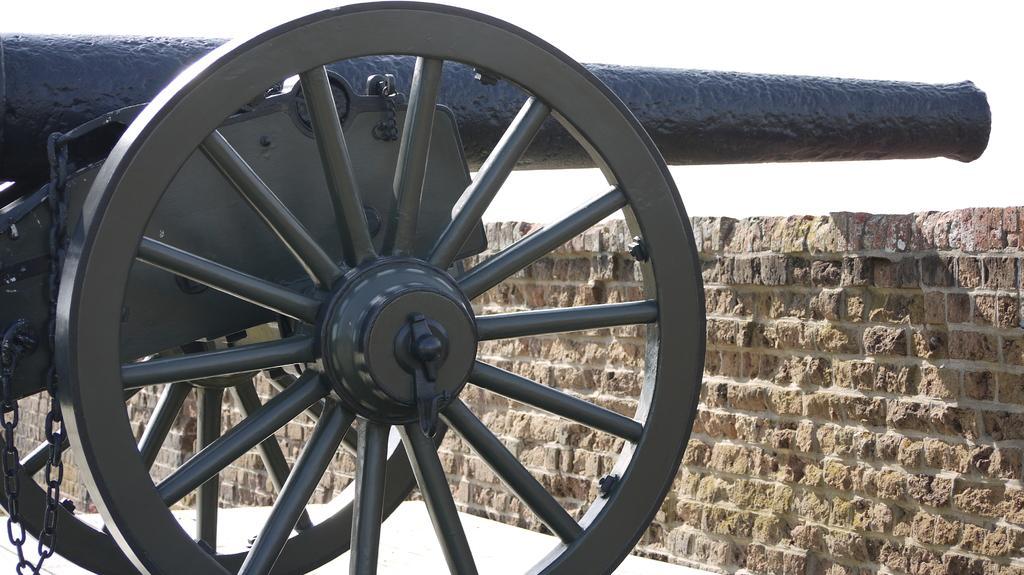Could you give a brief overview of what you see in this image? In this image I can see a cannon vehicle which is in black color. In front I can see brick wall. Background is in white color. 